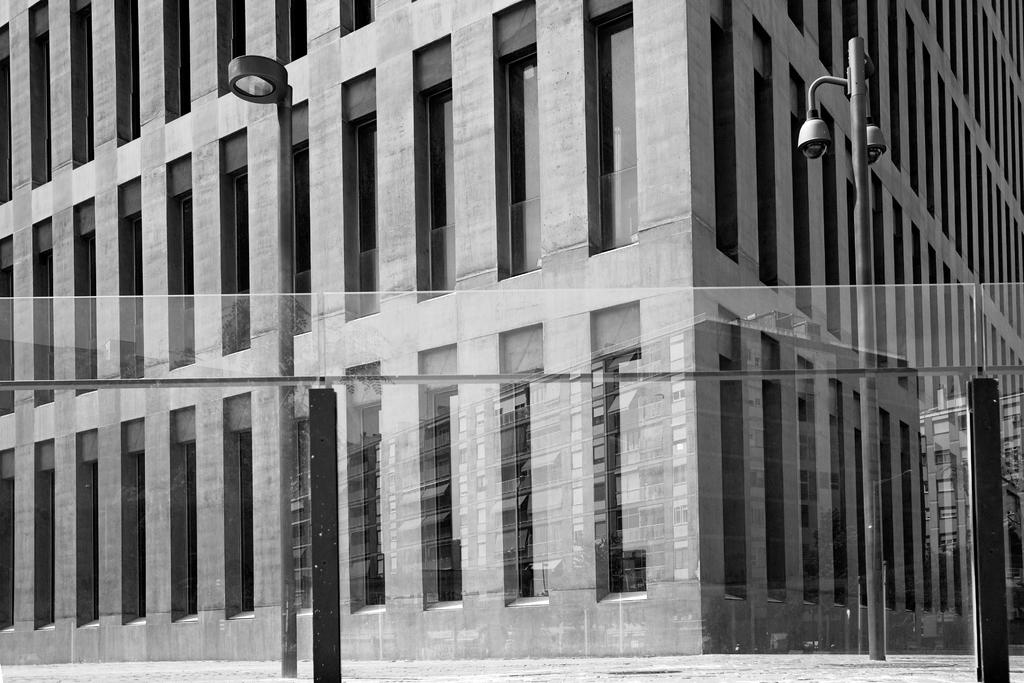What is the color scheme of the image? The image is in black and white. What structure can be seen in the image? There is a building in the image. What feature is present in the building? There are windows in the building. What other objects are visible in the image? There are poles and lights in the image. How many cows are standing on the stage in the image? There is no stage or cows present in the image. Can you describe the bee's behavior in the image? There is no bee present in the image. 